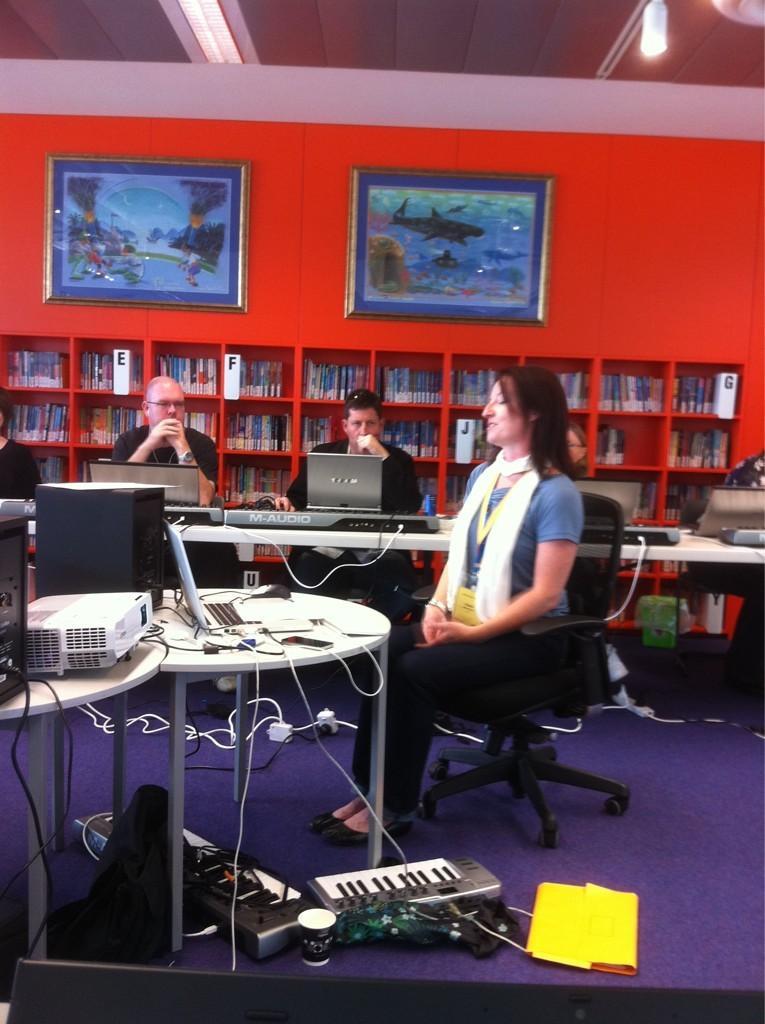How would you summarize this image in a sentence or two? It is a room there are lot of gadgets in the room there is a laptop on the table , in front of the table there is a woman sitting in the chair behind the woman there is a white color table on the table there are pianos and laptops ,in front of them there are few people sitting behind them there is a big bookstore with lot of books upside it ,there are two photo frames behind it in the background there is a red color wall. 